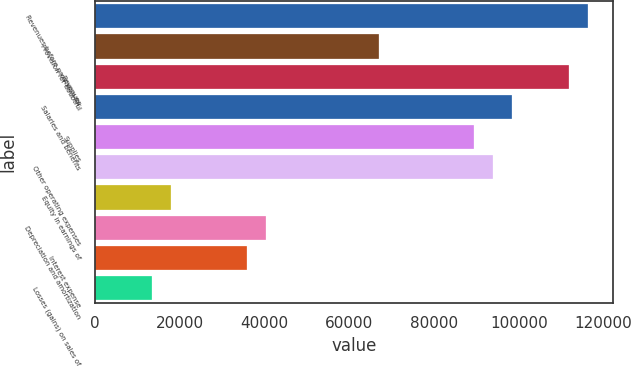Convert chart. <chart><loc_0><loc_0><loc_500><loc_500><bar_chart><fcel>Revenues before provision for<fcel>Provision for doubtful<fcel>Revenues<fcel>Salaries and benefits<fcel>Supplies<fcel>Other operating expenses<fcel>Equity in earnings of<fcel>Depreciation and amortization<fcel>Interest expense<fcel>Losses (gains) on sales of<nl><fcel>116336<fcel>67118.5<fcel>111862<fcel>98438.6<fcel>89490<fcel>93964.3<fcel>17901.2<fcel>40272.7<fcel>35798.4<fcel>13426.9<nl></chart> 